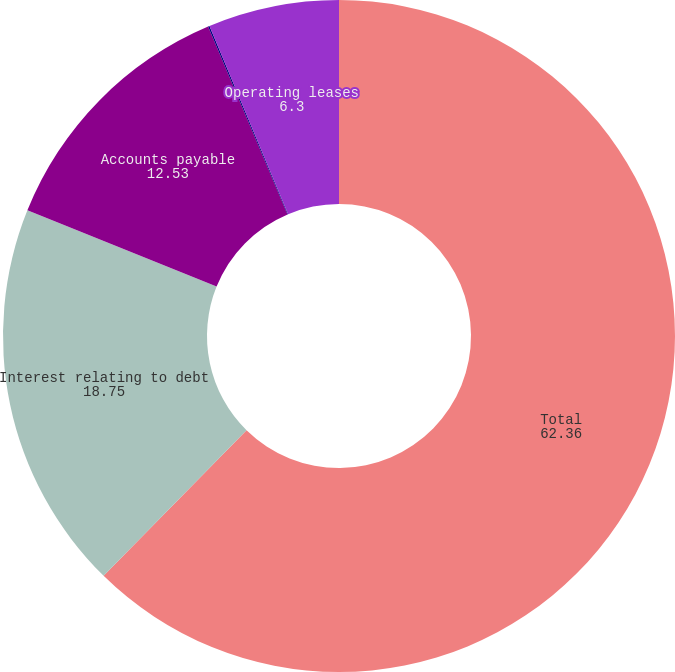Convert chart to OTSL. <chart><loc_0><loc_0><loc_500><loc_500><pie_chart><fcel>Total<fcel>Interest relating to debt<fcel>Accounts payable<fcel>Capital leases<fcel>Operating leases<nl><fcel>62.36%<fcel>18.75%<fcel>12.53%<fcel>0.07%<fcel>6.3%<nl></chart> 